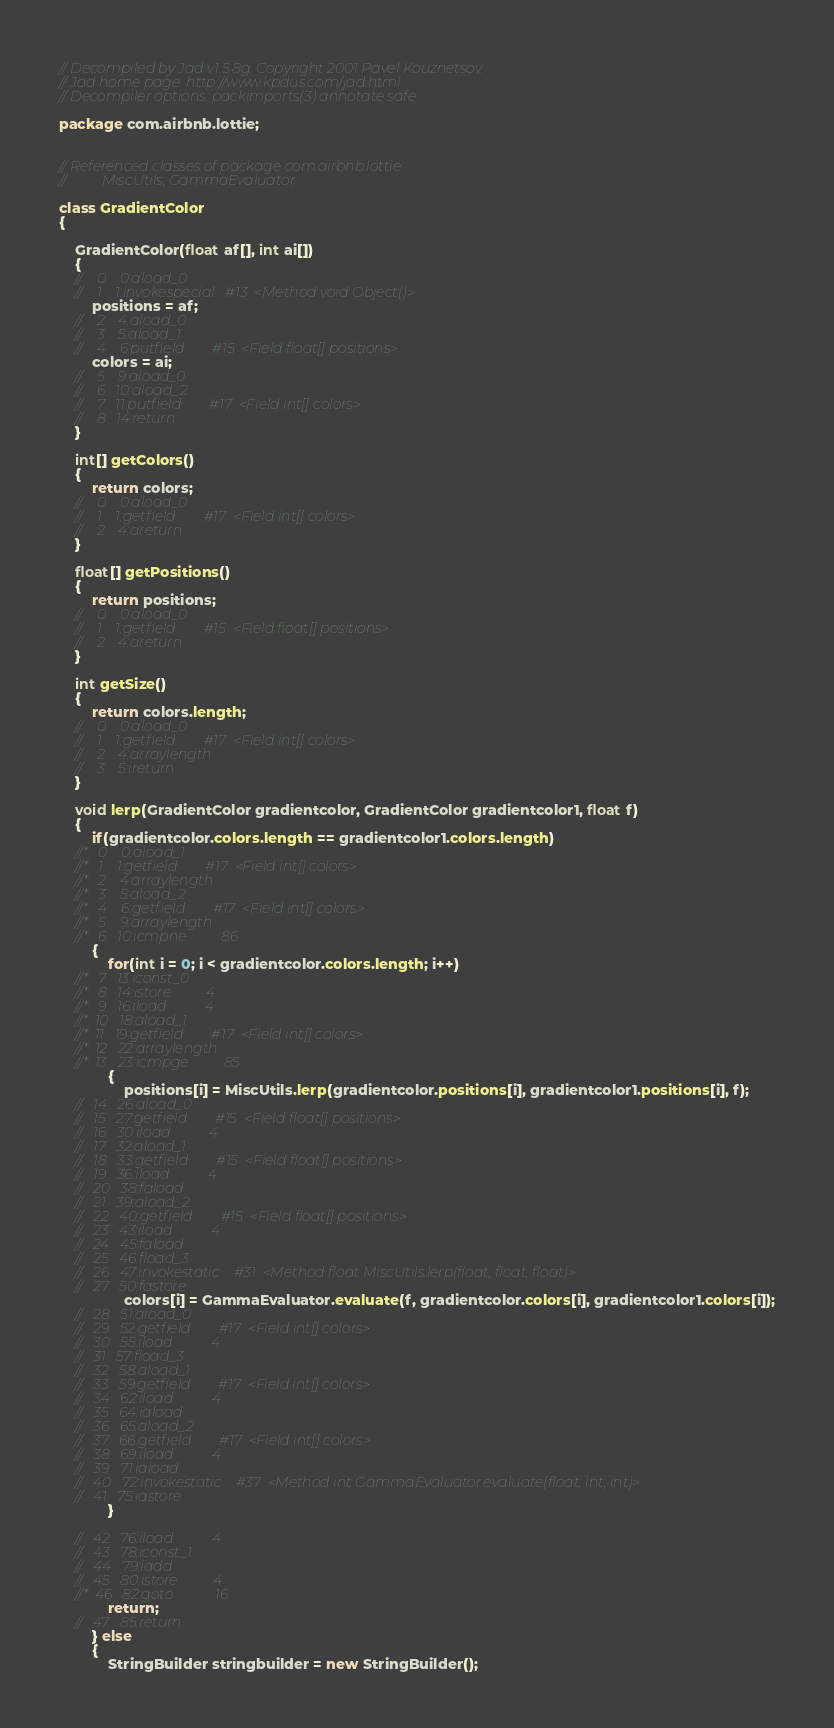<code> <loc_0><loc_0><loc_500><loc_500><_Java_>// Decompiled by Jad v1.5.8g. Copyright 2001 Pavel Kouznetsov.
// Jad home page: http://www.kpdus.com/jad.html
// Decompiler options: packimports(3) annotate safe 

package com.airbnb.lottie;


// Referenced classes of package com.airbnb.lottie:
//			MiscUtils, GammaEvaluator

class GradientColor
{

	GradientColor(float af[], int ai[])
	{
	//    0    0:aload_0         
	//    1    1:invokespecial   #13  <Method void Object()>
		positions = af;
	//    2    4:aload_0         
	//    3    5:aload_1         
	//    4    6:putfield        #15  <Field float[] positions>
		colors = ai;
	//    5    9:aload_0         
	//    6   10:aload_2         
	//    7   11:putfield        #17  <Field int[] colors>
	//    8   14:return          
	}

	int[] getColors()
	{
		return colors;
	//    0    0:aload_0         
	//    1    1:getfield        #17  <Field int[] colors>
	//    2    4:areturn         
	}

	float[] getPositions()
	{
		return positions;
	//    0    0:aload_0         
	//    1    1:getfield        #15  <Field float[] positions>
	//    2    4:areturn         
	}

	int getSize()
	{
		return colors.length;
	//    0    0:aload_0         
	//    1    1:getfield        #17  <Field int[] colors>
	//    2    4:arraylength     
	//    3    5:ireturn         
	}

	void lerp(GradientColor gradientcolor, GradientColor gradientcolor1, float f)
	{
		if(gradientcolor.colors.length == gradientcolor1.colors.length)
	//*   0    0:aload_1         
	//*   1    1:getfield        #17  <Field int[] colors>
	//*   2    4:arraylength     
	//*   3    5:aload_2         
	//*   4    6:getfield        #17  <Field int[] colors>
	//*   5    9:arraylength     
	//*   6   10:icmpne          86
		{
			for(int i = 0; i < gradientcolor.colors.length; i++)
	//*   7   13:iconst_0        
	//*   8   14:istore          4
	//*   9   16:iload           4
	//*  10   18:aload_1         
	//*  11   19:getfield        #17  <Field int[] colors>
	//*  12   22:arraylength     
	//*  13   23:icmpge          85
			{
				positions[i] = MiscUtils.lerp(gradientcolor.positions[i], gradientcolor1.positions[i], f);
	//   14   26:aload_0         
	//   15   27:getfield        #15  <Field float[] positions>
	//   16   30:iload           4
	//   17   32:aload_1         
	//   18   33:getfield        #15  <Field float[] positions>
	//   19   36:iload           4
	//   20   38:faload          
	//   21   39:aload_2         
	//   22   40:getfield        #15  <Field float[] positions>
	//   23   43:iload           4
	//   24   45:faload          
	//   25   46:fload_3         
	//   26   47:invokestatic    #31  <Method float MiscUtils.lerp(float, float, float)>
	//   27   50:fastore         
				colors[i] = GammaEvaluator.evaluate(f, gradientcolor.colors[i], gradientcolor1.colors[i]);
	//   28   51:aload_0         
	//   29   52:getfield        #17  <Field int[] colors>
	//   30   55:iload           4
	//   31   57:fload_3         
	//   32   58:aload_1         
	//   33   59:getfield        #17  <Field int[] colors>
	//   34   62:iload           4
	//   35   64:iaload          
	//   36   65:aload_2         
	//   37   66:getfield        #17  <Field int[] colors>
	//   38   69:iload           4
	//   39   71:iaload          
	//   40   72:invokestatic    #37  <Method int GammaEvaluator.evaluate(float, int, int)>
	//   41   75:iastore         
			}

	//   42   76:iload           4
	//   43   78:iconst_1        
	//   44   79:iadd            
	//   45   80:istore          4
	//*  46   82:goto            16
			return;
	//   47   85:return          
		} else
		{
			StringBuilder stringbuilder = new StringBuilder();</code> 